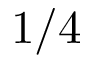Convert formula to latex. <formula><loc_0><loc_0><loc_500><loc_500>1 / 4</formula> 